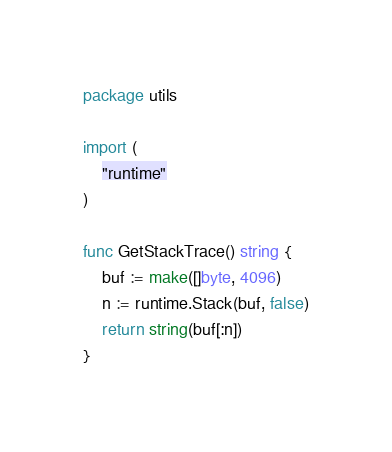<code> <loc_0><loc_0><loc_500><loc_500><_Go_>package utils

import (
	"runtime"
)

func GetStackTrace() string {
	buf := make([]byte, 4096)
	n := runtime.Stack(buf, false)
	return string(buf[:n])
}
</code> 